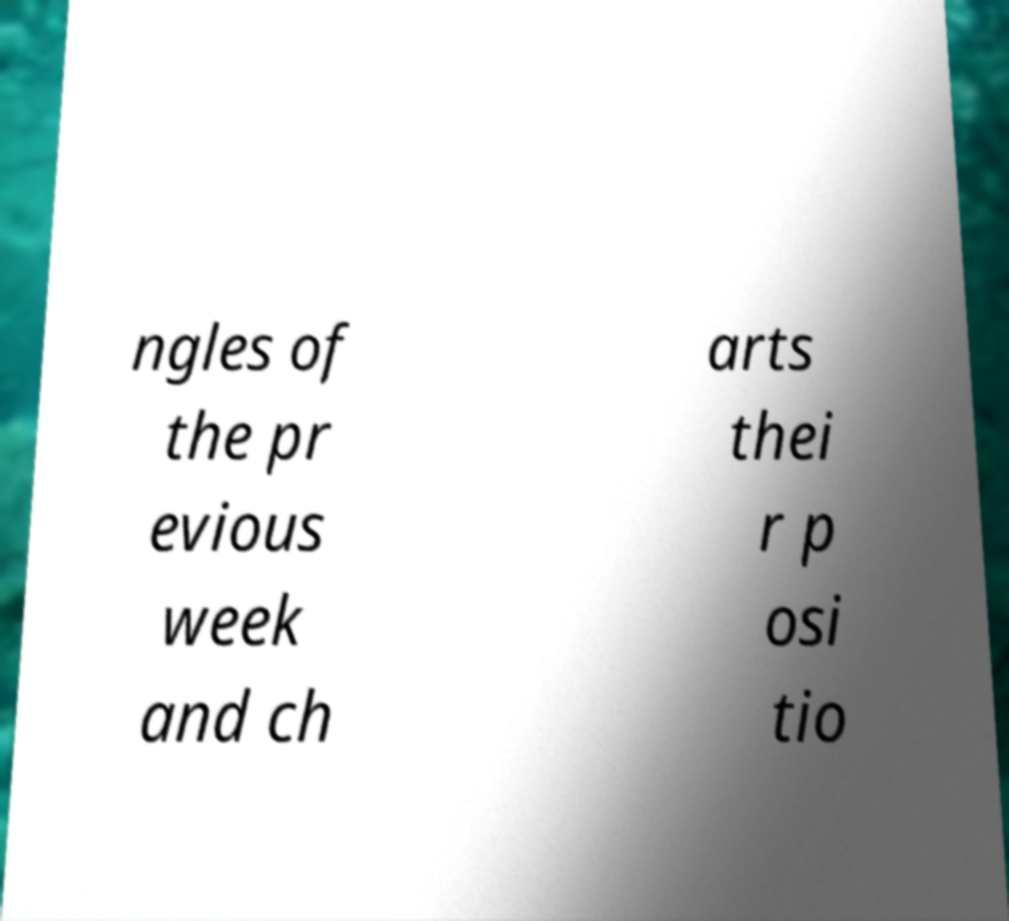I need the written content from this picture converted into text. Can you do that? ngles of the pr evious week and ch arts thei r p osi tio 